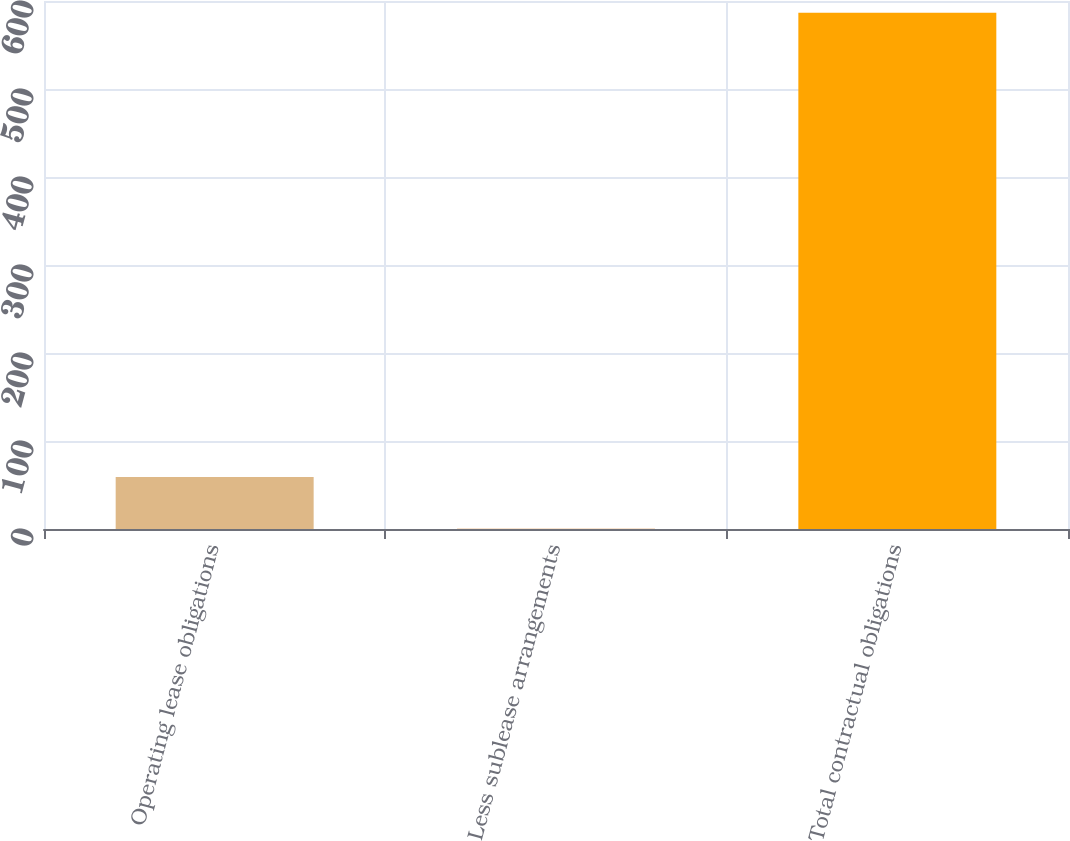Convert chart. <chart><loc_0><loc_0><loc_500><loc_500><bar_chart><fcel>Operating lease obligations<fcel>Less sublease arrangements<fcel>Total contractual obligations<nl><fcel>59.03<fcel>0.4<fcel>586.7<nl></chart> 